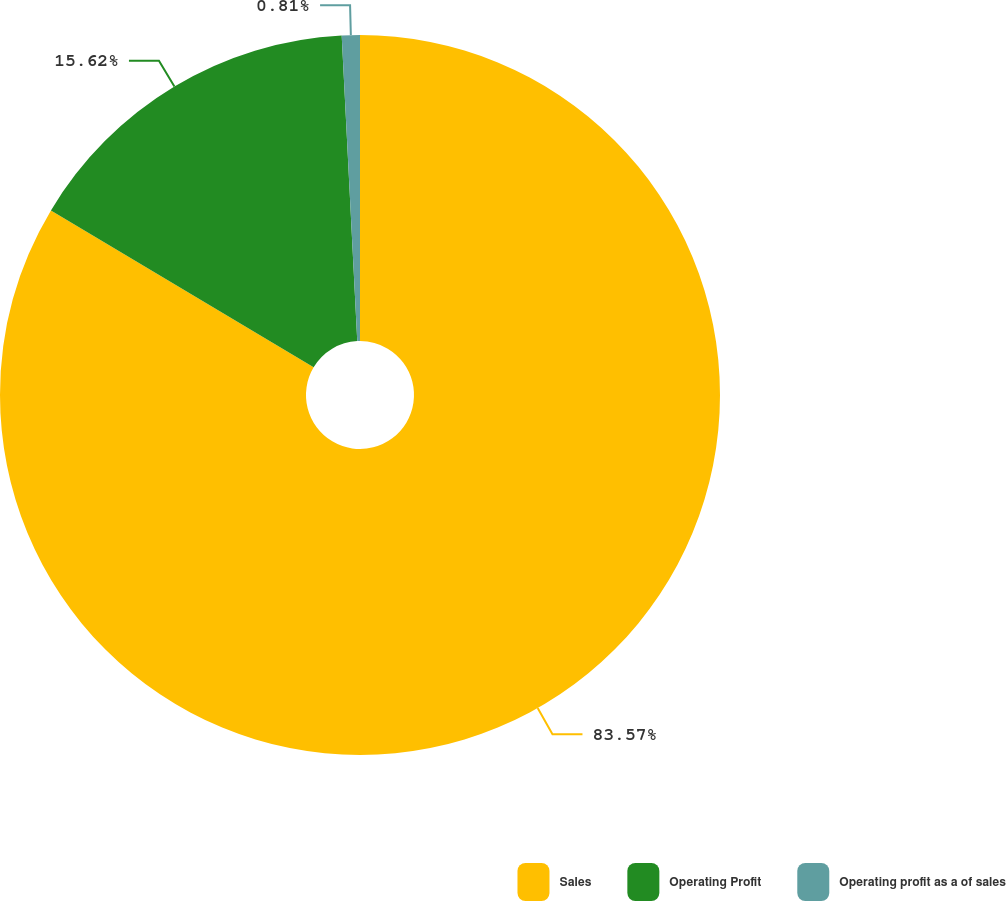Convert chart. <chart><loc_0><loc_0><loc_500><loc_500><pie_chart><fcel>Sales<fcel>Operating Profit<fcel>Operating profit as a of sales<nl><fcel>83.57%<fcel>15.62%<fcel>0.81%<nl></chart> 